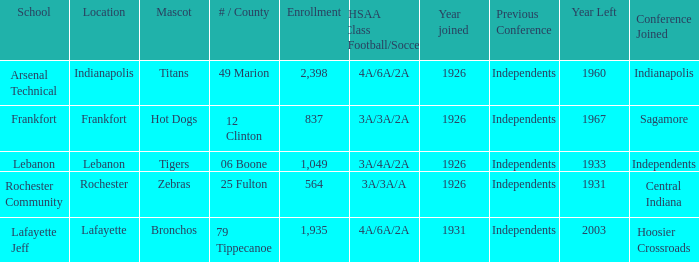What is the mean enrollment for institutions with hot dogs as their mascot and a joining date after 1926? None. 